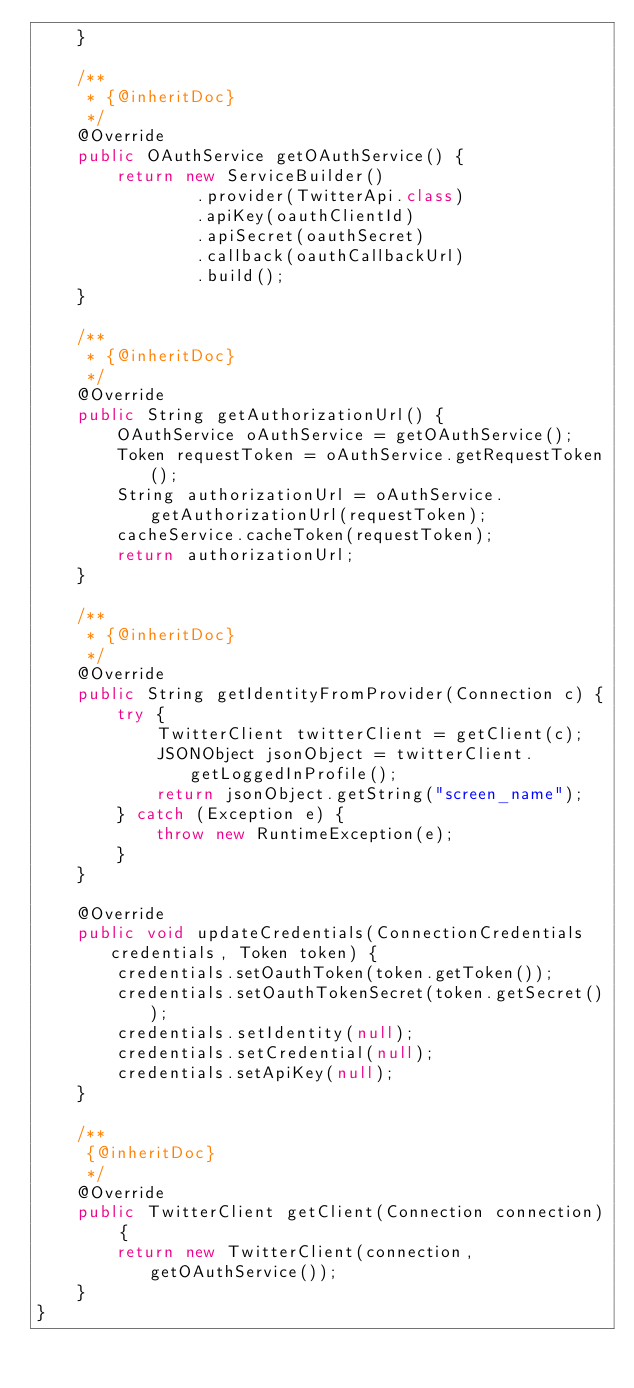Convert code to text. <code><loc_0><loc_0><loc_500><loc_500><_Java_>    }

    /**
     * {@inheritDoc}
     */
    @Override
    public OAuthService getOAuthService() {
        return new ServiceBuilder()
                .provider(TwitterApi.class)
                .apiKey(oauthClientId)
                .apiSecret(oauthSecret)
                .callback(oauthCallbackUrl)
                .build();
    }

    /**
     * {@inheritDoc}
     */
    @Override
    public String getAuthorizationUrl() {
        OAuthService oAuthService = getOAuthService();
        Token requestToken = oAuthService.getRequestToken();
        String authorizationUrl = oAuthService.getAuthorizationUrl(requestToken);
        cacheService.cacheToken(requestToken);
        return authorizationUrl;
    }

    /**
     * {@inheritDoc}
     */
    @Override
    public String getIdentityFromProvider(Connection c) {
        try {
            TwitterClient twitterClient = getClient(c);
            JSONObject jsonObject = twitterClient.getLoggedInProfile();
            return jsonObject.getString("screen_name");
        } catch (Exception e) {
            throw new RuntimeException(e);
        }
    }

    @Override
    public void updateCredentials(ConnectionCredentials credentials, Token token) {
        credentials.setOauthToken(token.getToken());
        credentials.setOauthTokenSecret(token.getSecret());
        credentials.setIdentity(null);
        credentials.setCredential(null);
        credentials.setApiKey(null);
    }

    /**
     {@inheritDoc}
     */
    @Override
    public TwitterClient getClient(Connection connection) {
        return new TwitterClient(connection,getOAuthService());
    }
}
</code> 